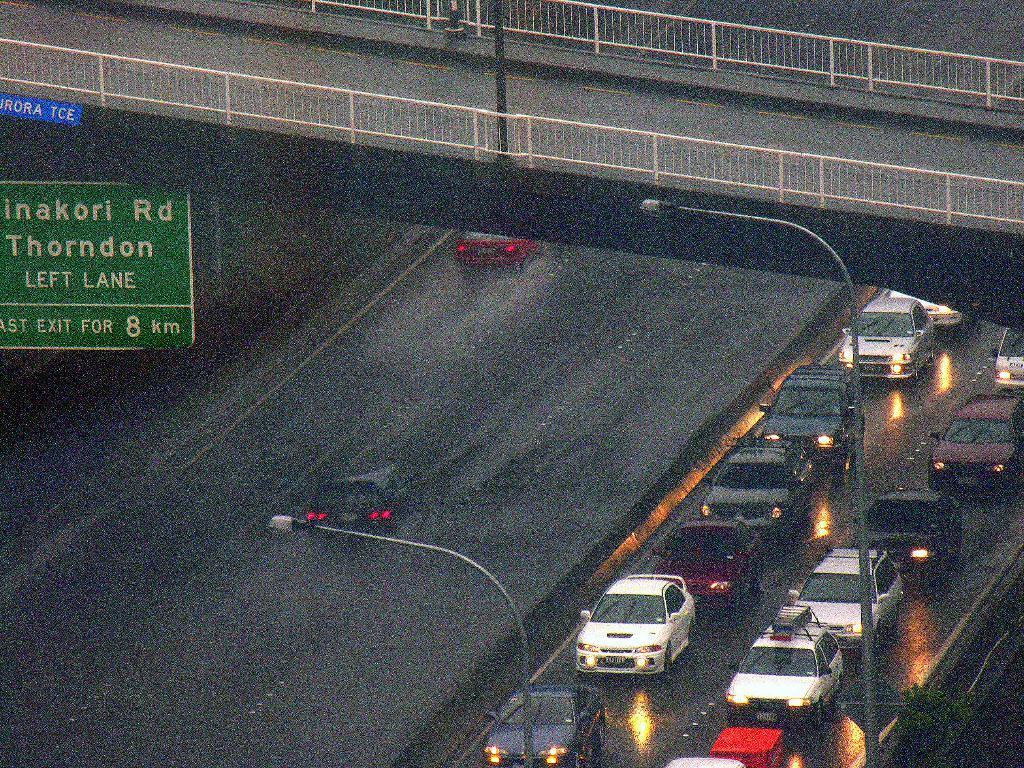Can you describe this image briefly? In this image I can see few vehicles, light poles and I can also see few boards in green and blue color. In the background I can see the railing. 